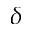<formula> <loc_0><loc_0><loc_500><loc_500>\delta</formula> 